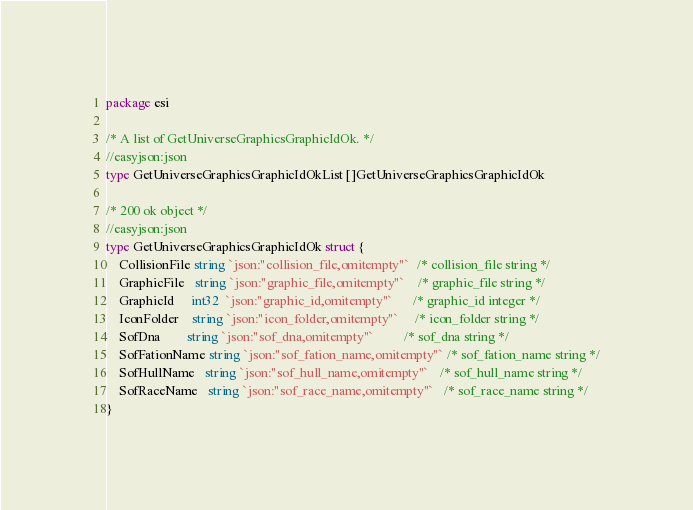<code> <loc_0><loc_0><loc_500><loc_500><_Go_>
package esi

/* A list of GetUniverseGraphicsGraphicIdOk. */
//easyjson:json
type GetUniverseGraphicsGraphicIdOkList []GetUniverseGraphicsGraphicIdOk

/* 200 ok object */
//easyjson:json
type GetUniverseGraphicsGraphicIdOk struct {
	CollisionFile string `json:"collision_file,omitempty"`  /* collision_file string */
	GraphicFile   string `json:"graphic_file,omitempty"`    /* graphic_file string */
	GraphicId     int32  `json:"graphic_id,omitempty"`      /* graphic_id integer */
	IconFolder    string `json:"icon_folder,omitempty"`     /* icon_folder string */
	SofDna        string `json:"sof_dna,omitempty"`         /* sof_dna string */
	SofFationName string `json:"sof_fation_name,omitempty"` /* sof_fation_name string */
	SofHullName   string `json:"sof_hull_name,omitempty"`   /* sof_hull_name string */
	SofRaceName   string `json:"sof_race_name,omitempty"`   /* sof_race_name string */
}
</code> 